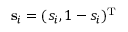Convert formula to latex. <formula><loc_0><loc_0><loc_500><loc_500>s _ { i } = ( s _ { i } , 1 - s _ { i } ) ^ { T }</formula> 